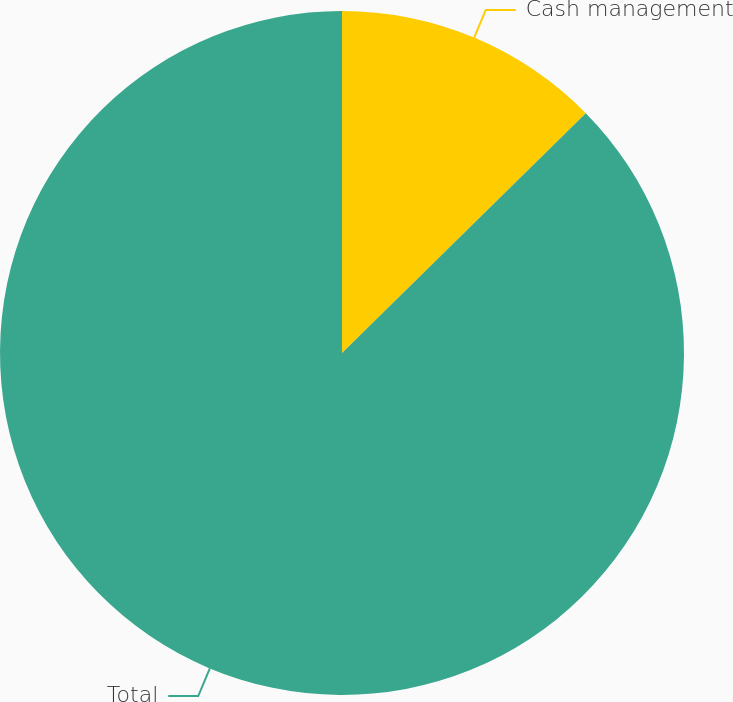<chart> <loc_0><loc_0><loc_500><loc_500><pie_chart><fcel>Cash management<fcel>Total<nl><fcel>12.63%<fcel>87.37%<nl></chart> 